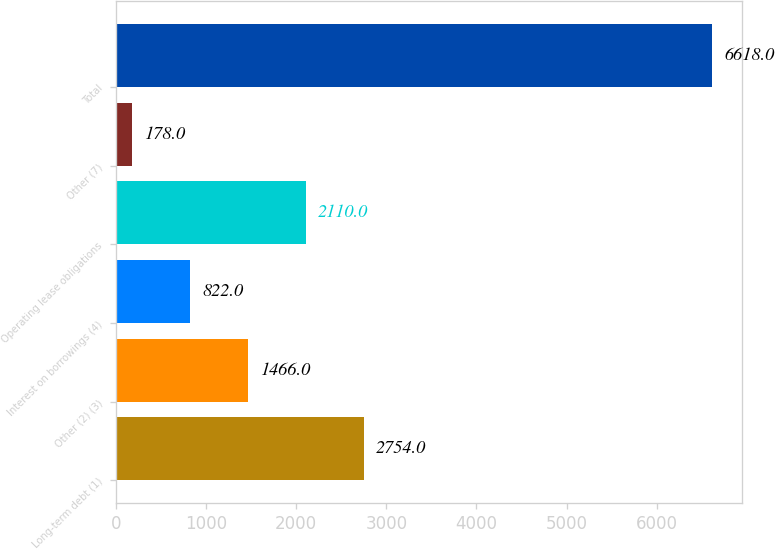Convert chart to OTSL. <chart><loc_0><loc_0><loc_500><loc_500><bar_chart><fcel>Long-term debt (1)<fcel>Other (2) (3)<fcel>Interest on borrowings (4)<fcel>Operating lease obligations<fcel>Other (7)<fcel>Total<nl><fcel>2754<fcel>1466<fcel>822<fcel>2110<fcel>178<fcel>6618<nl></chart> 